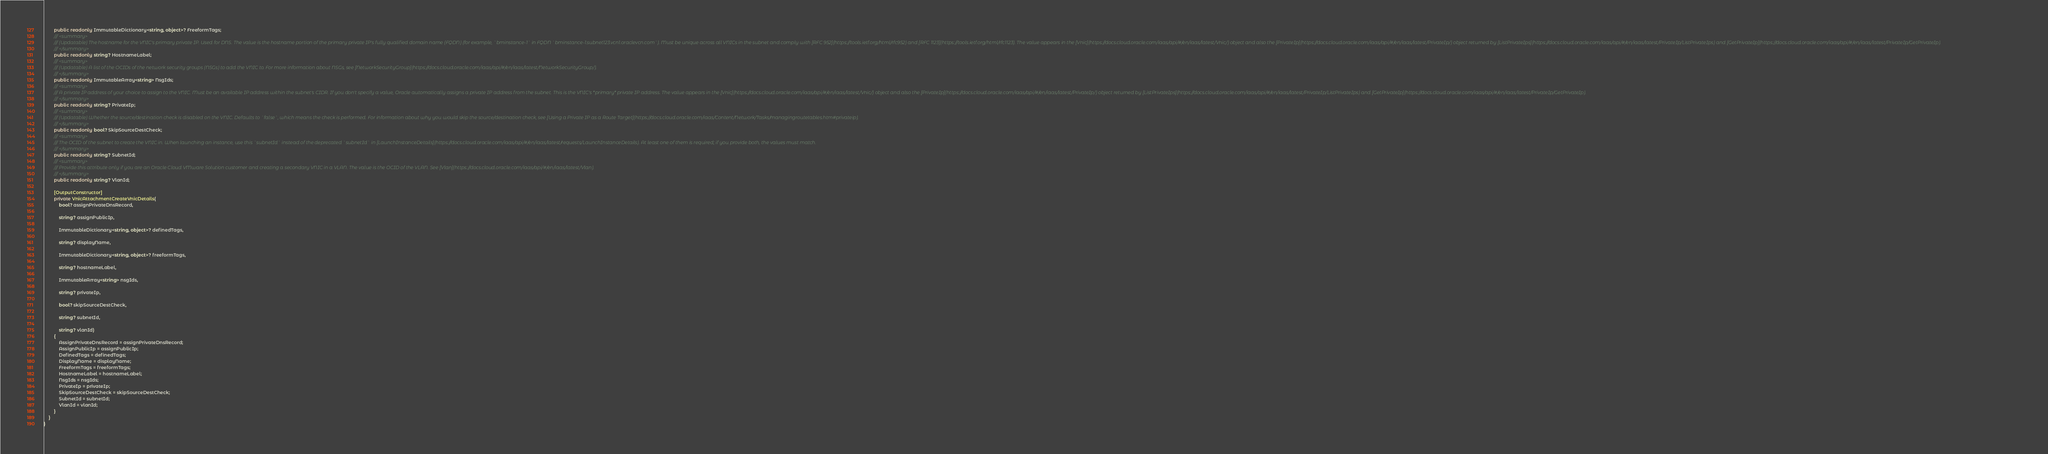<code> <loc_0><loc_0><loc_500><loc_500><_C#_>        public readonly ImmutableDictionary<string, object>? FreeformTags;
        /// <summary>
        /// (Updatable) The hostname for the VNIC's primary private IP. Used for DNS. The value is the hostname portion of the primary private IP's fully qualified domain name (FQDN) (for example, `bminstance-1` in FQDN `bminstance-1.subnet123.vcn1.oraclevcn.com`). Must be unique across all VNICs in the subnet and comply with [RFC 952](https://tools.ietf.org/html/rfc952) and [RFC 1123](https://tools.ietf.org/html/rfc1123). The value appears in the [Vnic](https://docs.cloud.oracle.com/iaas/api/#/en/iaas/latest/Vnic/) object and also the [PrivateIp](https://docs.cloud.oracle.com/iaas/api/#/en/iaas/latest/PrivateIp/) object returned by [ListPrivateIps](https://docs.cloud.oracle.com/iaas/api/#/en/iaas/latest/PrivateIp/ListPrivateIps) and [GetPrivateIp](https://docs.cloud.oracle.com/iaas/api/#/en/iaas/latest/PrivateIp/GetPrivateIp).
        /// </summary>
        public readonly string? HostnameLabel;
        /// <summary>
        /// (Updatable) A list of the OCIDs of the network security groups (NSGs) to add the VNIC to. For more information about NSGs, see [NetworkSecurityGroup](https://docs.cloud.oracle.com/iaas/api/#/en/iaas/latest/NetworkSecurityGroup/).
        /// </summary>
        public readonly ImmutableArray<string> NsgIds;
        /// <summary>
        /// A private IP address of your choice to assign to the VNIC. Must be an available IP address within the subnet's CIDR. If you don't specify a value, Oracle automatically assigns a private IP address from the subnet. This is the VNIC's *primary* private IP address. The value appears in the [Vnic](https://docs.cloud.oracle.com/iaas/api/#/en/iaas/latest/Vnic/) object and also the [PrivateIp](https://docs.cloud.oracle.com/iaas/api/#/en/iaas/latest/PrivateIp/) object returned by [ListPrivateIps](https://docs.cloud.oracle.com/iaas/api/#/en/iaas/latest/PrivateIp/ListPrivateIps) and [GetPrivateIp](https://docs.cloud.oracle.com/iaas/api/#/en/iaas/latest/PrivateIp/GetPrivateIp).
        /// </summary>
        public readonly string? PrivateIp;
        /// <summary>
        /// (Updatable) Whether the source/destination check is disabled on the VNIC. Defaults to `false`, which means the check is performed. For information about why you would skip the source/destination check, see [Using a Private IP as a Route Target](https://docs.cloud.oracle.com/iaas/Content/Network/Tasks/managingroutetables.htm#privateip).
        /// </summary>
        public readonly bool? SkipSourceDestCheck;
        /// <summary>
        /// The OCID of the subnet to create the VNIC in. When launching an instance, use this `subnetId` instead of the deprecated `subnetId` in [LaunchInstanceDetails](https://docs.cloud.oracle.com/iaas/api/#/en/iaas/latest/requests/LaunchInstanceDetails). At least one of them is required; if you provide both, the values must match.
        /// </summary>
        public readonly string? SubnetId;
        /// <summary>
        /// Provide this attribute only if you are an Oracle Cloud VMware Solution customer and creating a secondary VNIC in a VLAN. The value is the OCID of the VLAN. See [Vlan](https://docs.cloud.oracle.com/iaas/api/#/en/iaas/latest/Vlan).
        /// </summary>
        public readonly string? VlanId;

        [OutputConstructor]
        private VnicAttachmentCreateVnicDetails(
            bool? assignPrivateDnsRecord,

            string? assignPublicIp,

            ImmutableDictionary<string, object>? definedTags,

            string? displayName,

            ImmutableDictionary<string, object>? freeformTags,

            string? hostnameLabel,

            ImmutableArray<string> nsgIds,

            string? privateIp,

            bool? skipSourceDestCheck,

            string? subnetId,

            string? vlanId)
        {
            AssignPrivateDnsRecord = assignPrivateDnsRecord;
            AssignPublicIp = assignPublicIp;
            DefinedTags = definedTags;
            DisplayName = displayName;
            FreeformTags = freeformTags;
            HostnameLabel = hostnameLabel;
            NsgIds = nsgIds;
            PrivateIp = privateIp;
            SkipSourceDestCheck = skipSourceDestCheck;
            SubnetId = subnetId;
            VlanId = vlanId;
        }
    }
}
</code> 